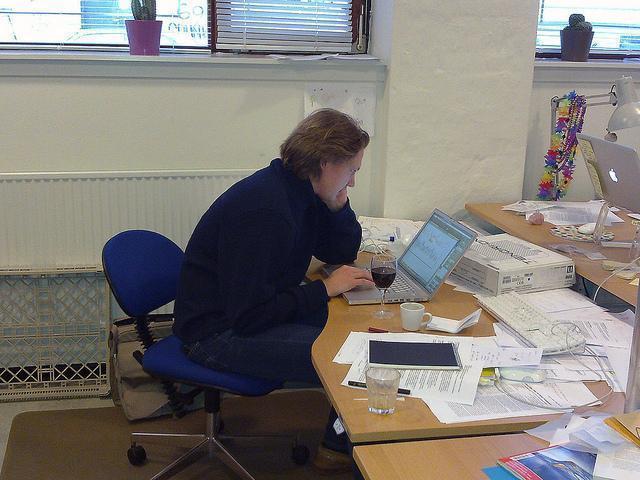Which liquid is most likely to be spilled on a laptop here?
Choose the right answer from the provided options to respond to the question.
Options: Milk, water, milkshake, red wine. Red wine. 